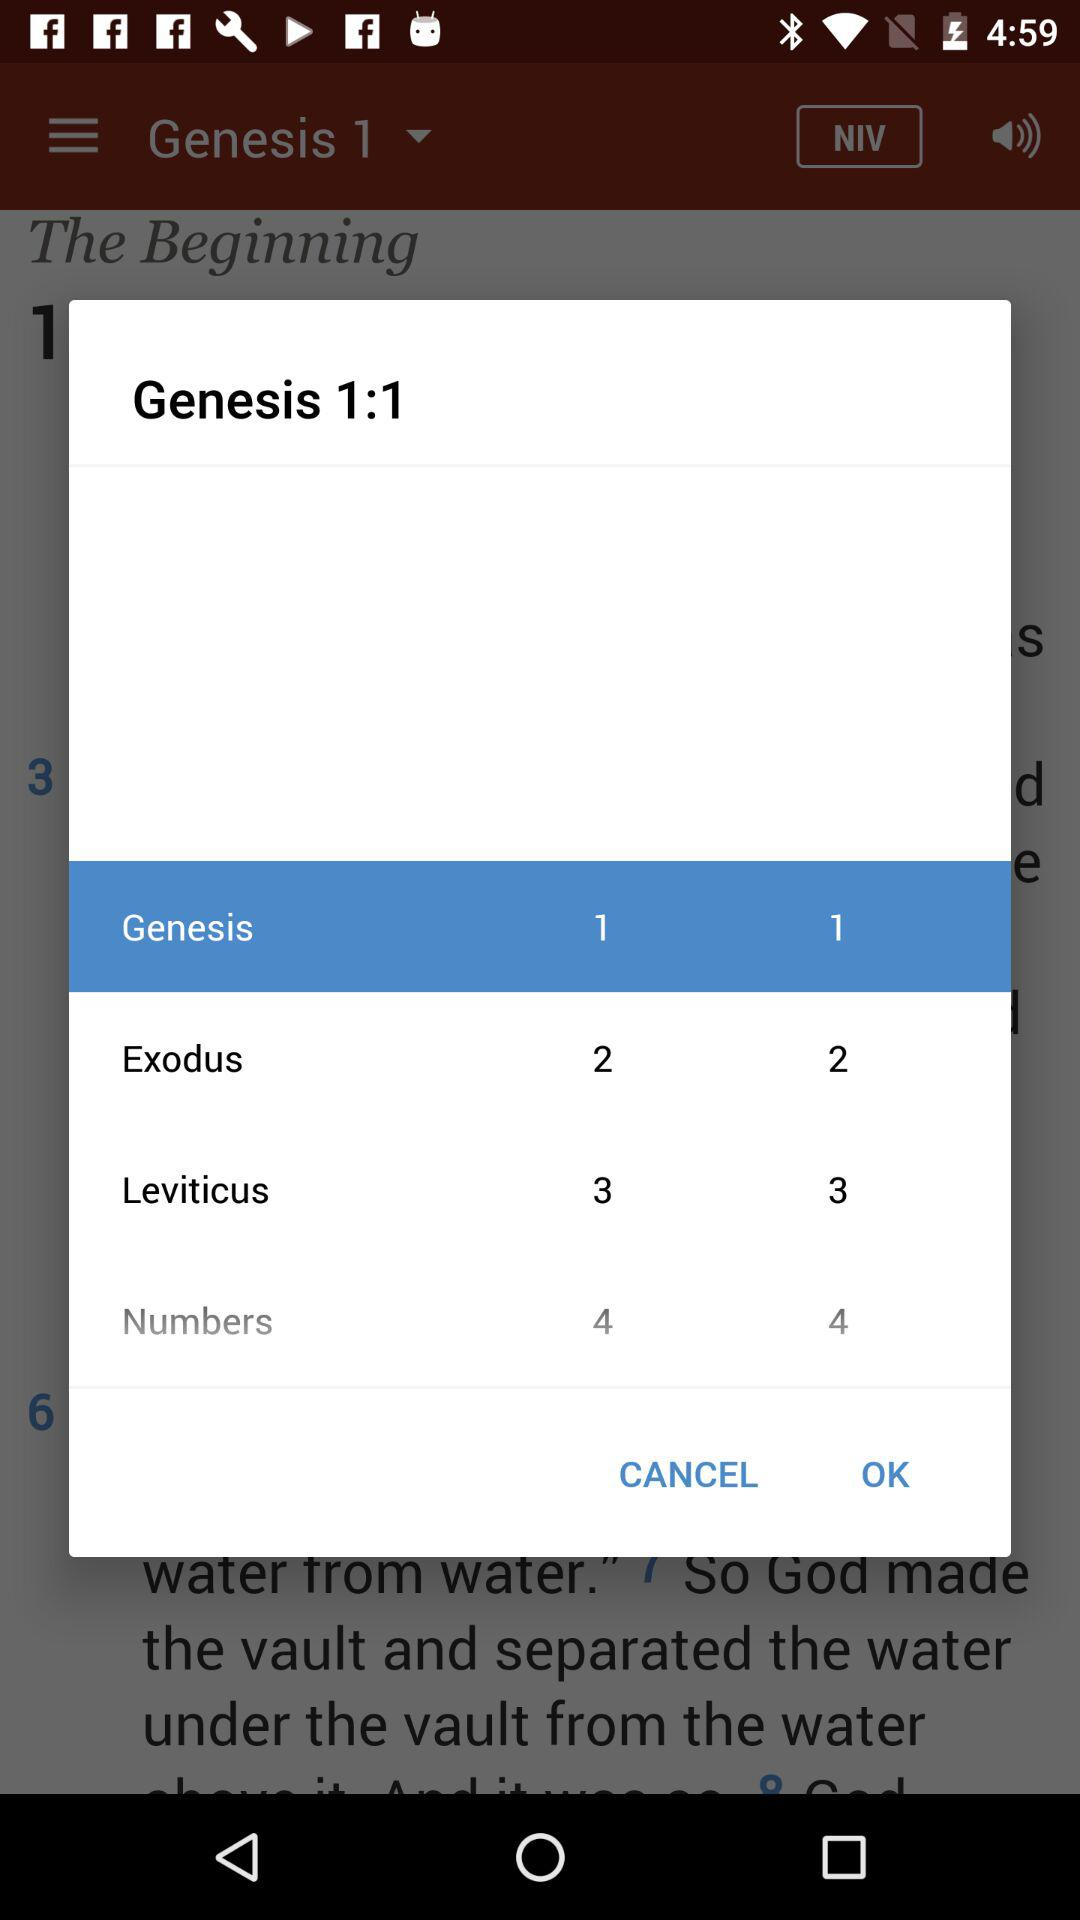What is the ratio of Leviticus?
When the provided information is insufficient, respond with <no answer>. <no answer> 